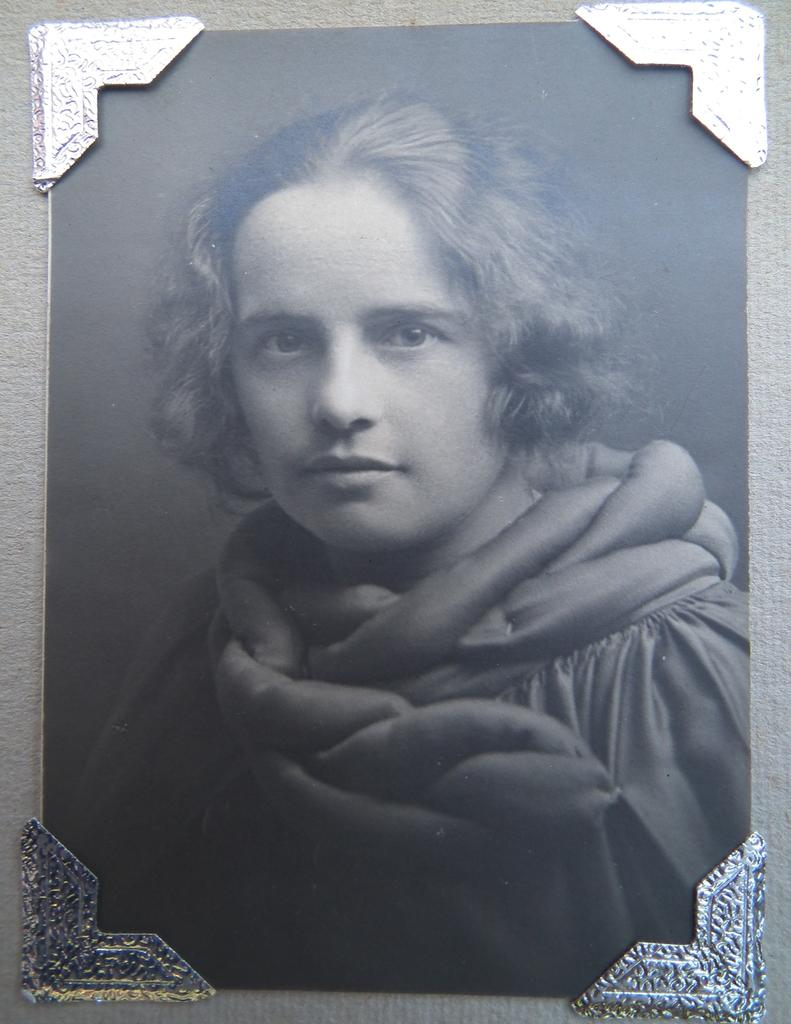What object is present in the image that typically holds a photo? There is a photo frame in the image. Where is the photo frame located? The photo frame is on a platform. What can be seen inside the photo frame? There is a photo of a girl in the frame. Is there a hose visible in the image? No, there is no hose present in the image. Is the girl in the photo frame poisoned? There is no indication in the image that the girl in the photo frame is poisoned. 